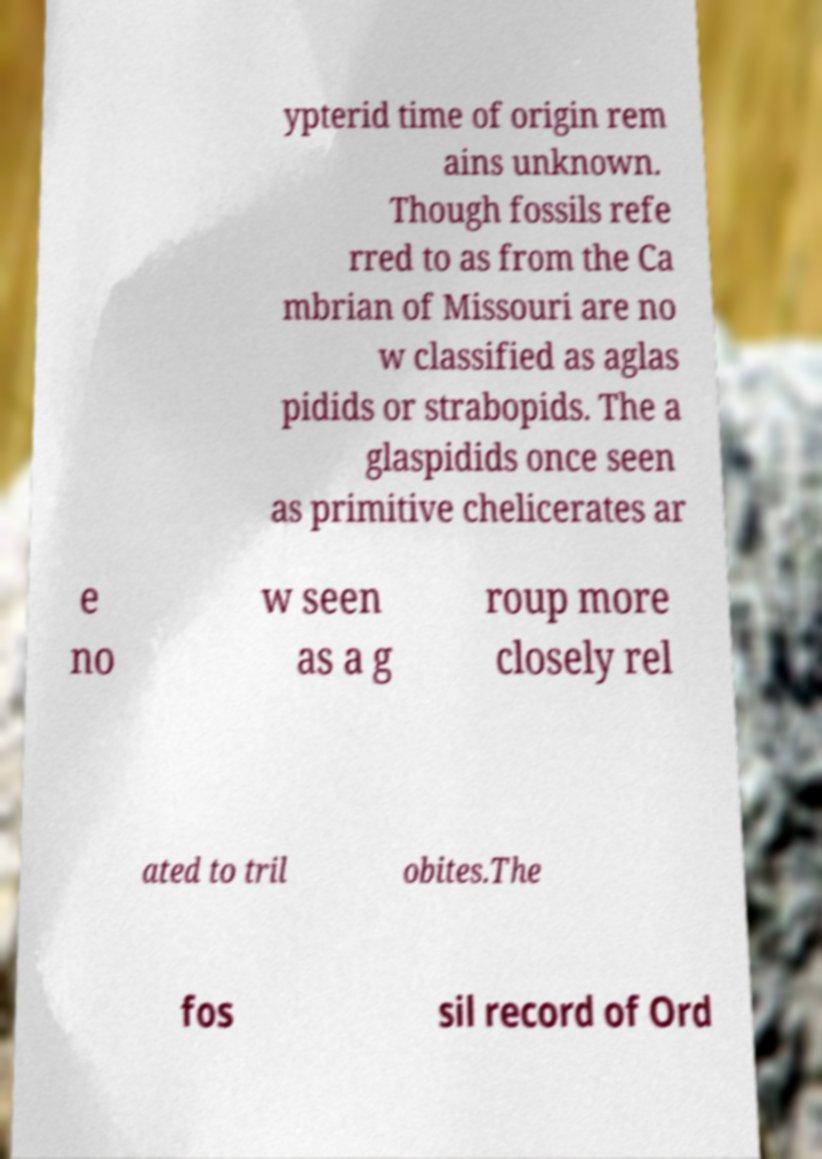Could you extract and type out the text from this image? ypterid time of origin rem ains unknown. Though fossils refe rred to as from the Ca mbrian of Missouri are no w classified as aglas pidids or strabopids. The a glaspidids once seen as primitive chelicerates ar e no w seen as a g roup more closely rel ated to tril obites.The fos sil record of Ord 